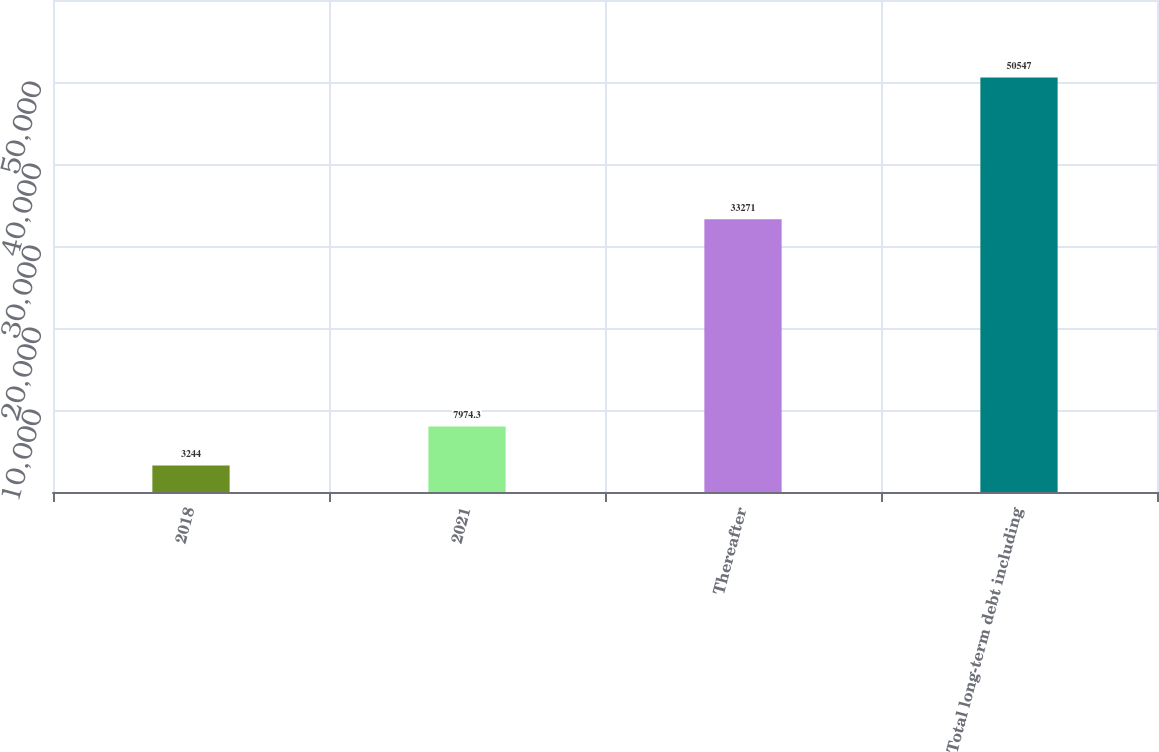Convert chart. <chart><loc_0><loc_0><loc_500><loc_500><bar_chart><fcel>2018<fcel>2021<fcel>Thereafter<fcel>Total long-term debt including<nl><fcel>3244<fcel>7974.3<fcel>33271<fcel>50547<nl></chart> 